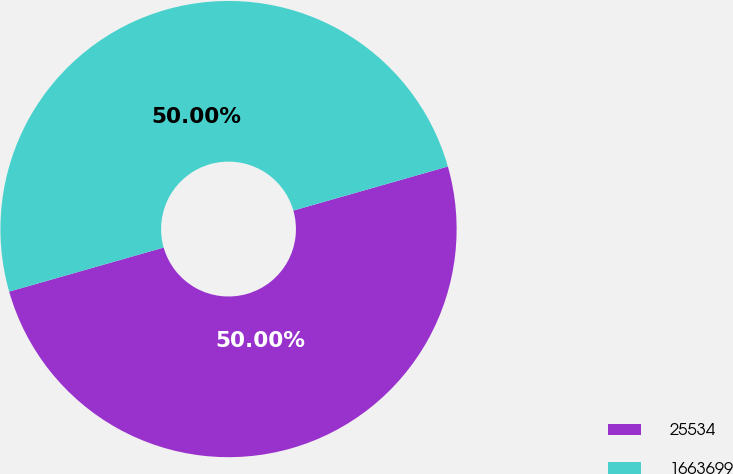<chart> <loc_0><loc_0><loc_500><loc_500><pie_chart><fcel>25534<fcel>1663699<nl><fcel>50.0%<fcel>50.0%<nl></chart> 